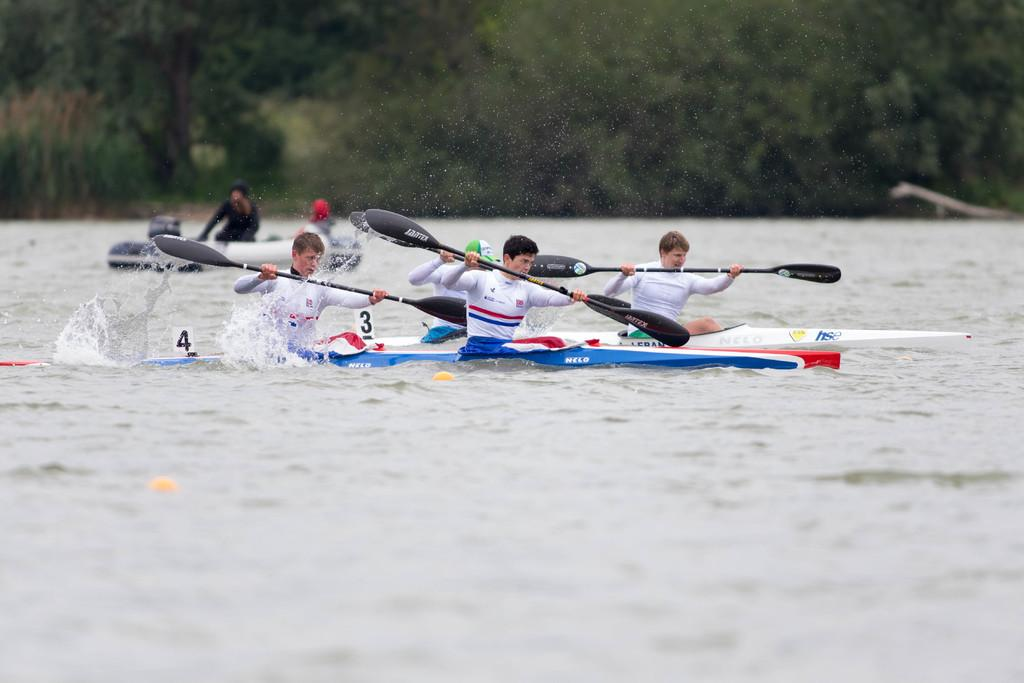What are the men in the image doing? The men in the image are riding boats. Where are the boats located? The boats are on the water. What can be seen in the background of the image? There are trees in the background of the image. What is the tendency of the balls in the image? There are no balls present in the image. 